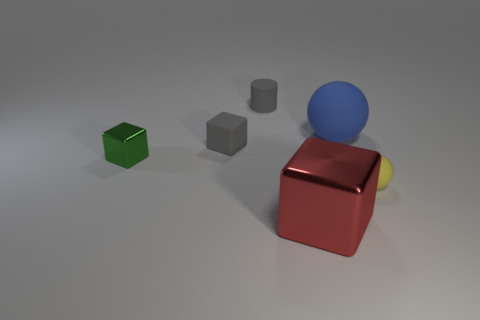There is another red thing that is the same shape as the tiny shiny object; what size is it?
Your answer should be compact. Large. How big is the red cube?
Provide a succinct answer. Large. Are there fewer big metal blocks that are to the right of the blue matte thing than red things?
Offer a terse response. Yes. Do the yellow rubber object and the green cube have the same size?
Provide a short and direct response. Yes. There is a tiny cube that is the same material as the big red thing; what color is it?
Offer a very short reply. Green. Are there fewer matte spheres that are behind the small ball than small green metallic cubes behind the large sphere?
Offer a very short reply. No. What number of tiny matte objects have the same color as the small cylinder?
Keep it short and to the point. 1. What is the material of the small object that is the same color as the small matte block?
Make the answer very short. Rubber. What number of small objects are left of the big red shiny thing and on the right side of the red object?
Your response must be concise. 0. What is the big object that is in front of the big thing on the right side of the red metallic block made of?
Offer a terse response. Metal. 